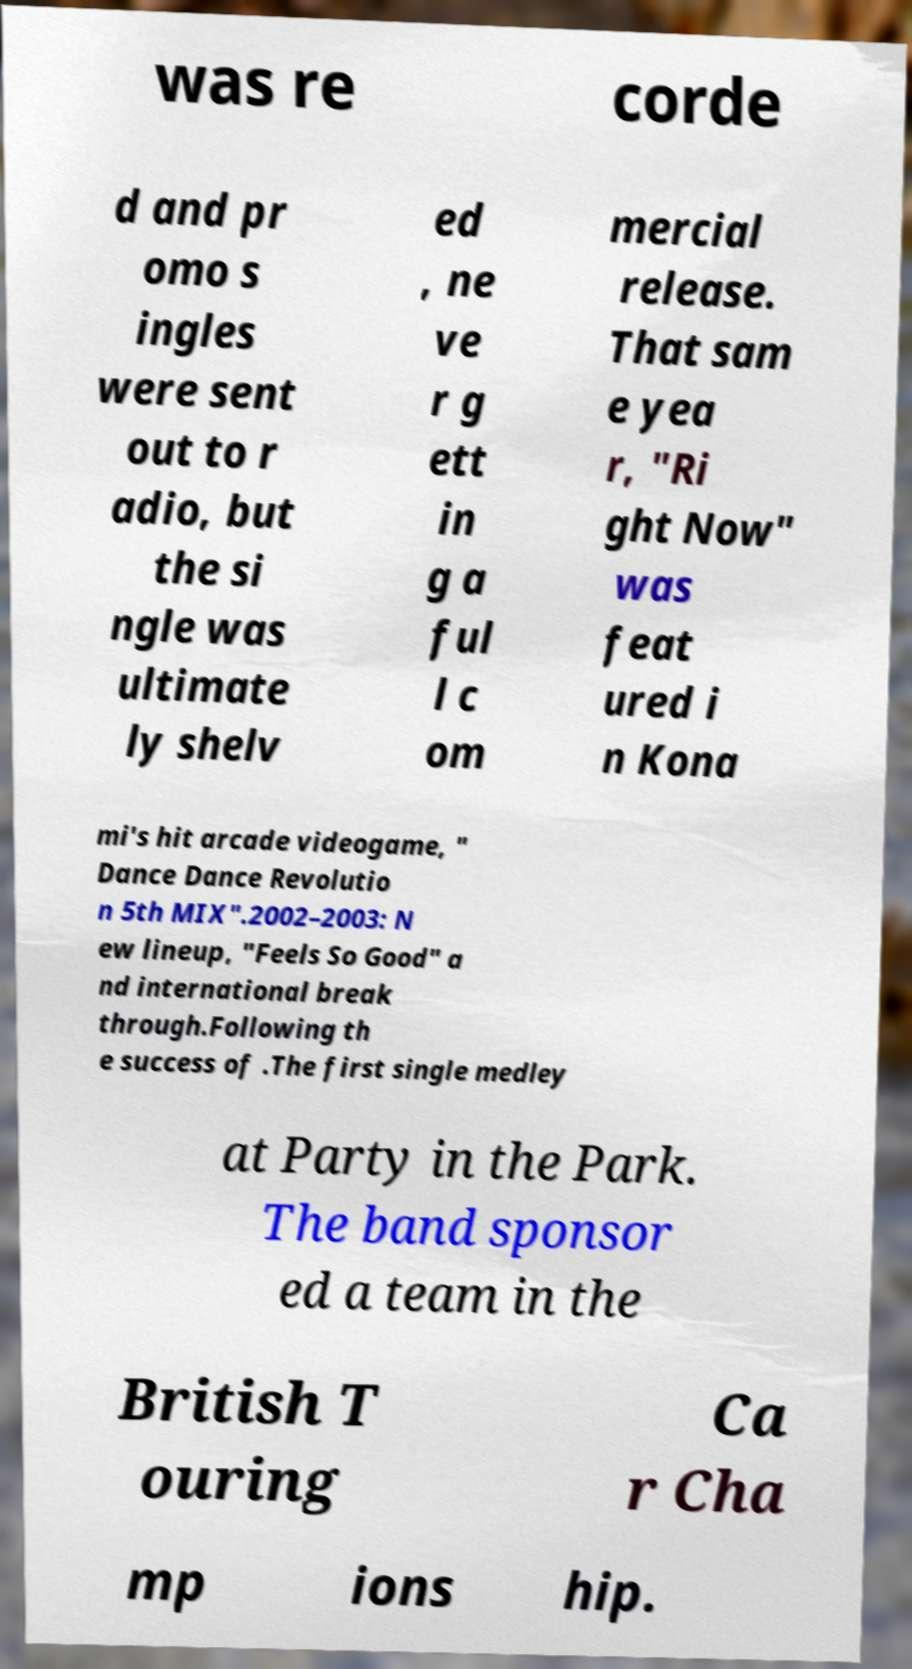Can you accurately transcribe the text from the provided image for me? was re corde d and pr omo s ingles were sent out to r adio, but the si ngle was ultimate ly shelv ed , ne ve r g ett in g a ful l c om mercial release. That sam e yea r, "Ri ght Now" was feat ured i n Kona mi's hit arcade videogame, " Dance Dance Revolutio n 5th MIX".2002–2003: N ew lineup, "Feels So Good" a nd international break through.Following th e success of .The first single medley at Party in the Park. The band sponsor ed a team in the British T ouring Ca r Cha mp ions hip. 